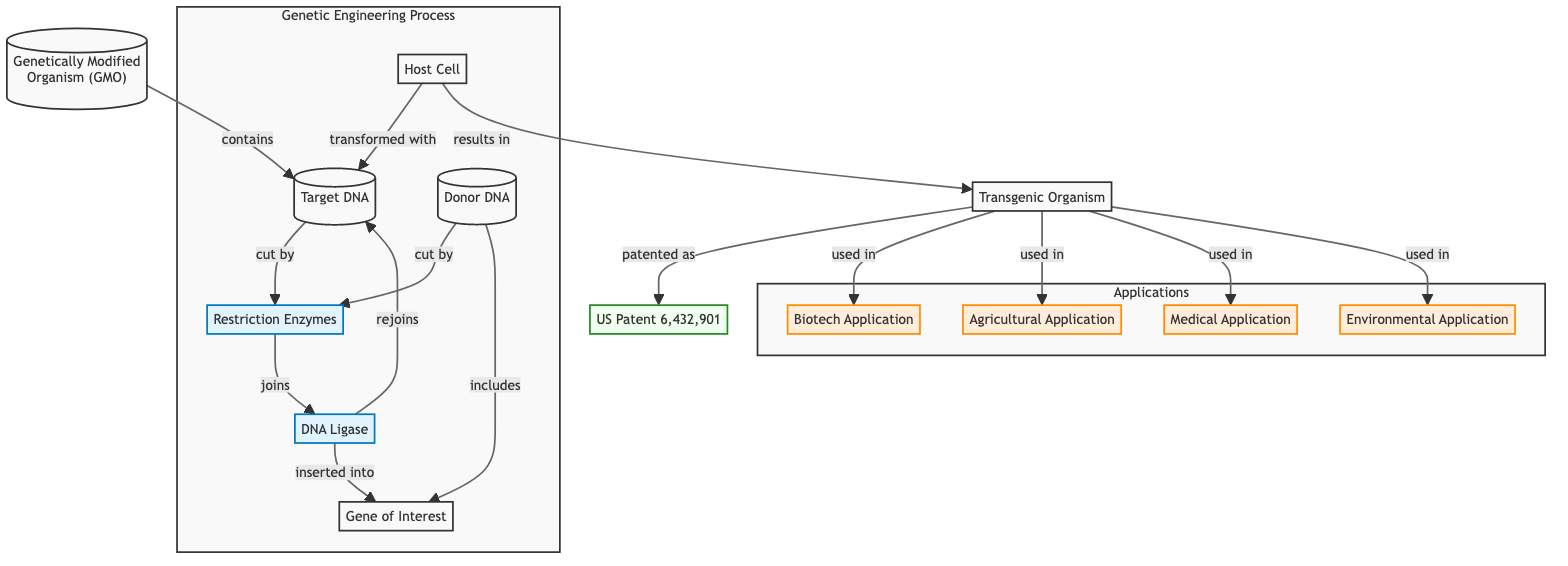What is the main subject of the diagram? The diagram centers around the structure and processes of a genetically modified organism (GMO) as indicated by the title node labeled "Genetically Modified Organism (GMO)".
Answer: Genetically Modified Organism (GMO) How many applications are listed in the diagram? The diagram lists four distinct applications of the transgenic organism: Biotech Application, Agricultural Application, Medical Application, and Environmental Application, as shown in the applications subgraph.
Answer: Four Which enzyme is involved in the genetic engineering process? The diagram highlights "Restriction Enzymes" as a key component in the genetic engineering process, connecting the target DNA and donor DNA nodes.
Answer: Restriction Enzymes What is the relationship between the Host Cell and the Transgenic Organism? The diagram shows that the Host Cell is transformed with the Target DNA, which results in the Transgenic Organism, illustrating a direct causal relationship.
Answer: Transformed with Which patent is specifically associated with the Transgenic Organism? The diagram indicates that the Transgenic Organism is patented as "US Patent 6,432,901", which directly connects the transgenic organism to its patent.
Answer: US Patent 6,432,901 What component joins the donor DNA to the target DNA in the diagram? The diagram depicts "DNA Ligase" as the component that re-joins the fragments of DNA, linking the actions of restriction enzymes and the process of genetic modification.
Answer: DNA Ligase Which application is related to biotechnology? Among the applications listed, "Biotech Application" is distinctly shown in the diagram as a primary use of the transgenic organism.
Answer: Biotech Application What does the Donor DNA include? The diagram specifies that the Donor DNA includes the "Gene of Interest", indicating that this gene is a crucial part of the genetic modification process.
Answer: Gene of Interest What results from the transformation of the Host Cell in the genetic engineering process? The transformation of the Host Cell with the Target DNA directly results in the creation of a Transgenic Organism, as represented in the flow of the diagram.
Answer: Transgenic Organism 